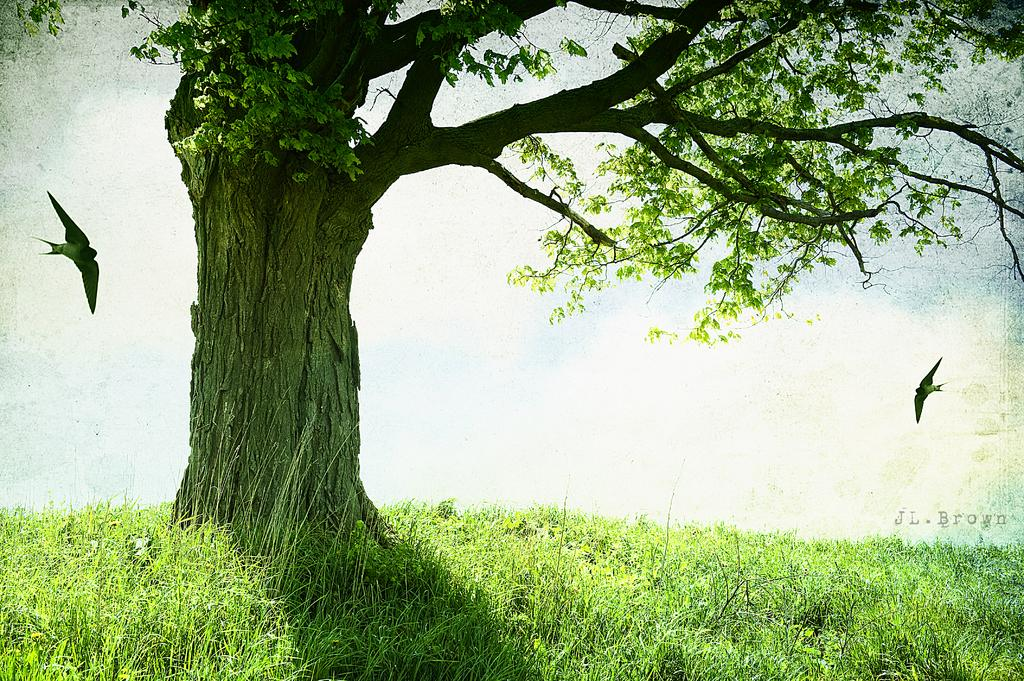What type of plant can be seen in the image? There is a tree in the image. What type of vegetation is present on the ground in the image? There is grass in the image. What type of animals are visible in the image? There are birds in the image. What part of the natural environment is visible in the image? The sky is visible in the image. What type of room is visible in the image? There is no room present in the image; it features a tree, grass, birds, and the sky. How many ducks can be seen falling from the tree in the image? There are no ducks present in the image, and therefore no ducks are falling from the tree. 